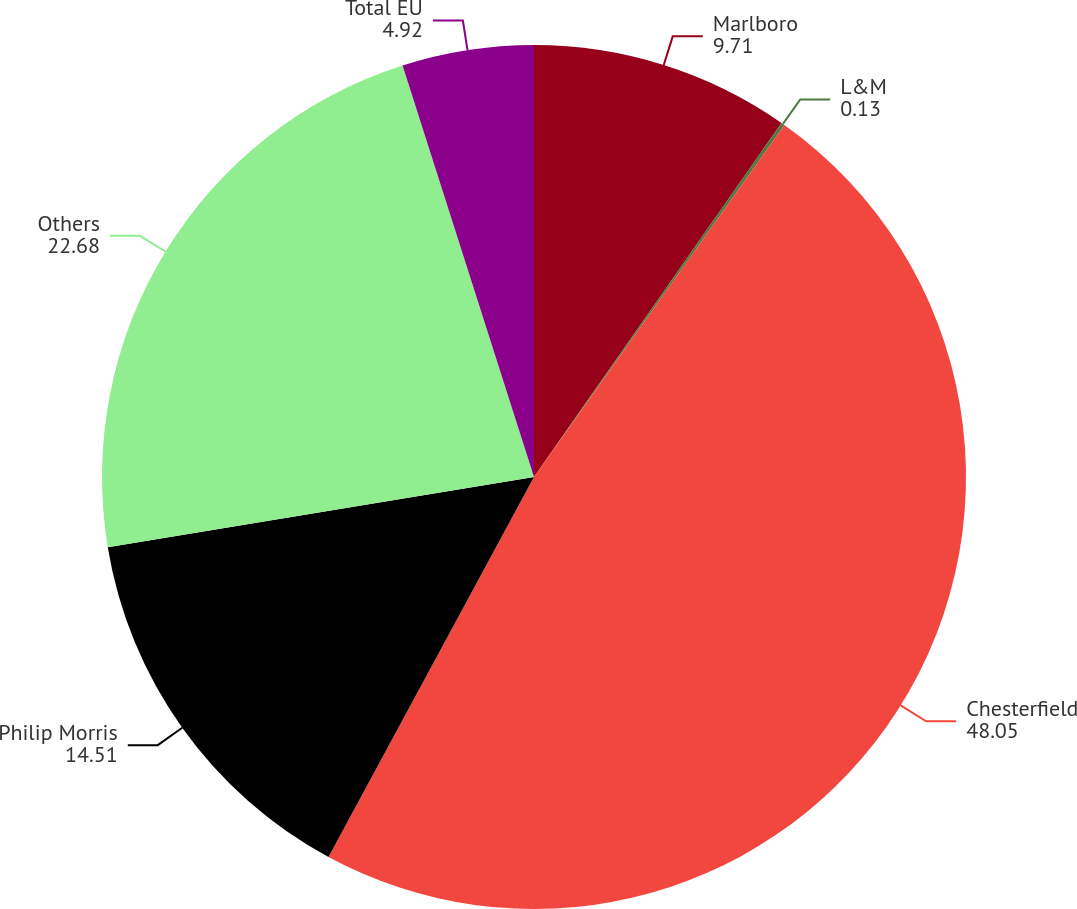Convert chart to OTSL. <chart><loc_0><loc_0><loc_500><loc_500><pie_chart><fcel>Marlboro<fcel>L&M<fcel>Chesterfield<fcel>Philip Morris<fcel>Others<fcel>Total EU<nl><fcel>9.71%<fcel>0.13%<fcel>48.05%<fcel>14.51%<fcel>22.68%<fcel>4.92%<nl></chart> 